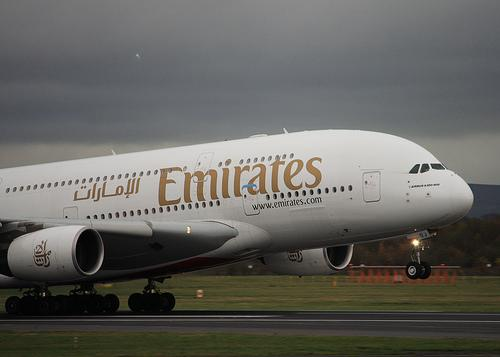What type of advertisement can be created based on the details in the image? An advertisement for a gold and white airplane or an airline featuring this airplane can be created. In a visual Entailment task, consider the statement: "The airplane is on a grass field." Based on the details given, is this statement true or false? False, the airplane is on an asphalt ground, not a grass field. Name one aspect of the environment surrounding the airplane. There are white clouds in the blue sky surrounding the airplane. Please describe a notable feature of the airplane in the image. The airplane has a gold and white color scheme with a logo painted on it. Identify the surface on which the airplane is located. The airplane is located on an asphalt ground. What is the primary color of the airplane in the image? The primary color of the airplane is white. Mention the color and main component of the airplane that can be seen through its window. The cockpit with gray-colored sky can be seen through the airplane window. From the given details, can you identify the type of vehicle in the image? Yes, the vehicle in the image is an airplane. In a multi-choice VQA task, choose the correct statement from the options below: a) The sky is blue and cloudy, and b) The ground is made of asphalt. 